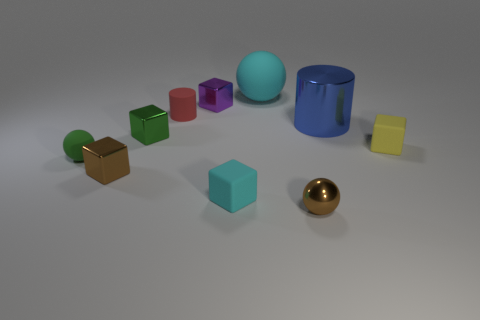Is there any other thing that is the same size as the red cylinder?
Make the answer very short. Yes. There is a tiny object that is the same color as the big matte ball; what is its shape?
Provide a succinct answer. Cube. The large metallic object is what shape?
Make the answer very short. Cylinder. There is a cylinder that is on the right side of the small cylinder; what is its size?
Your answer should be compact. Large. What color is the matte sphere that is the same size as the rubber cylinder?
Give a very brief answer. Green. Is there a small metallic sphere of the same color as the large matte ball?
Your answer should be very brief. No. Are there fewer small yellow matte objects in front of the purple block than small brown objects that are in front of the tiny cyan matte block?
Offer a very short reply. No. There is a object that is on the right side of the brown metallic ball and left of the tiny yellow thing; what is it made of?
Offer a very short reply. Metal. There is a yellow thing; is its shape the same as the brown metallic thing that is on the left side of the tiny red matte cylinder?
Your answer should be very brief. Yes. What number of other things are the same size as the blue metallic cylinder?
Offer a very short reply. 1. 